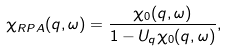<formula> <loc_0><loc_0><loc_500><loc_500>\chi _ { R P A } ( { q } , \omega ) = \frac { \chi _ { 0 } ( { q } , \omega ) } { 1 - U _ { q } \chi _ { 0 } ( { q } , \omega ) } ,</formula> 